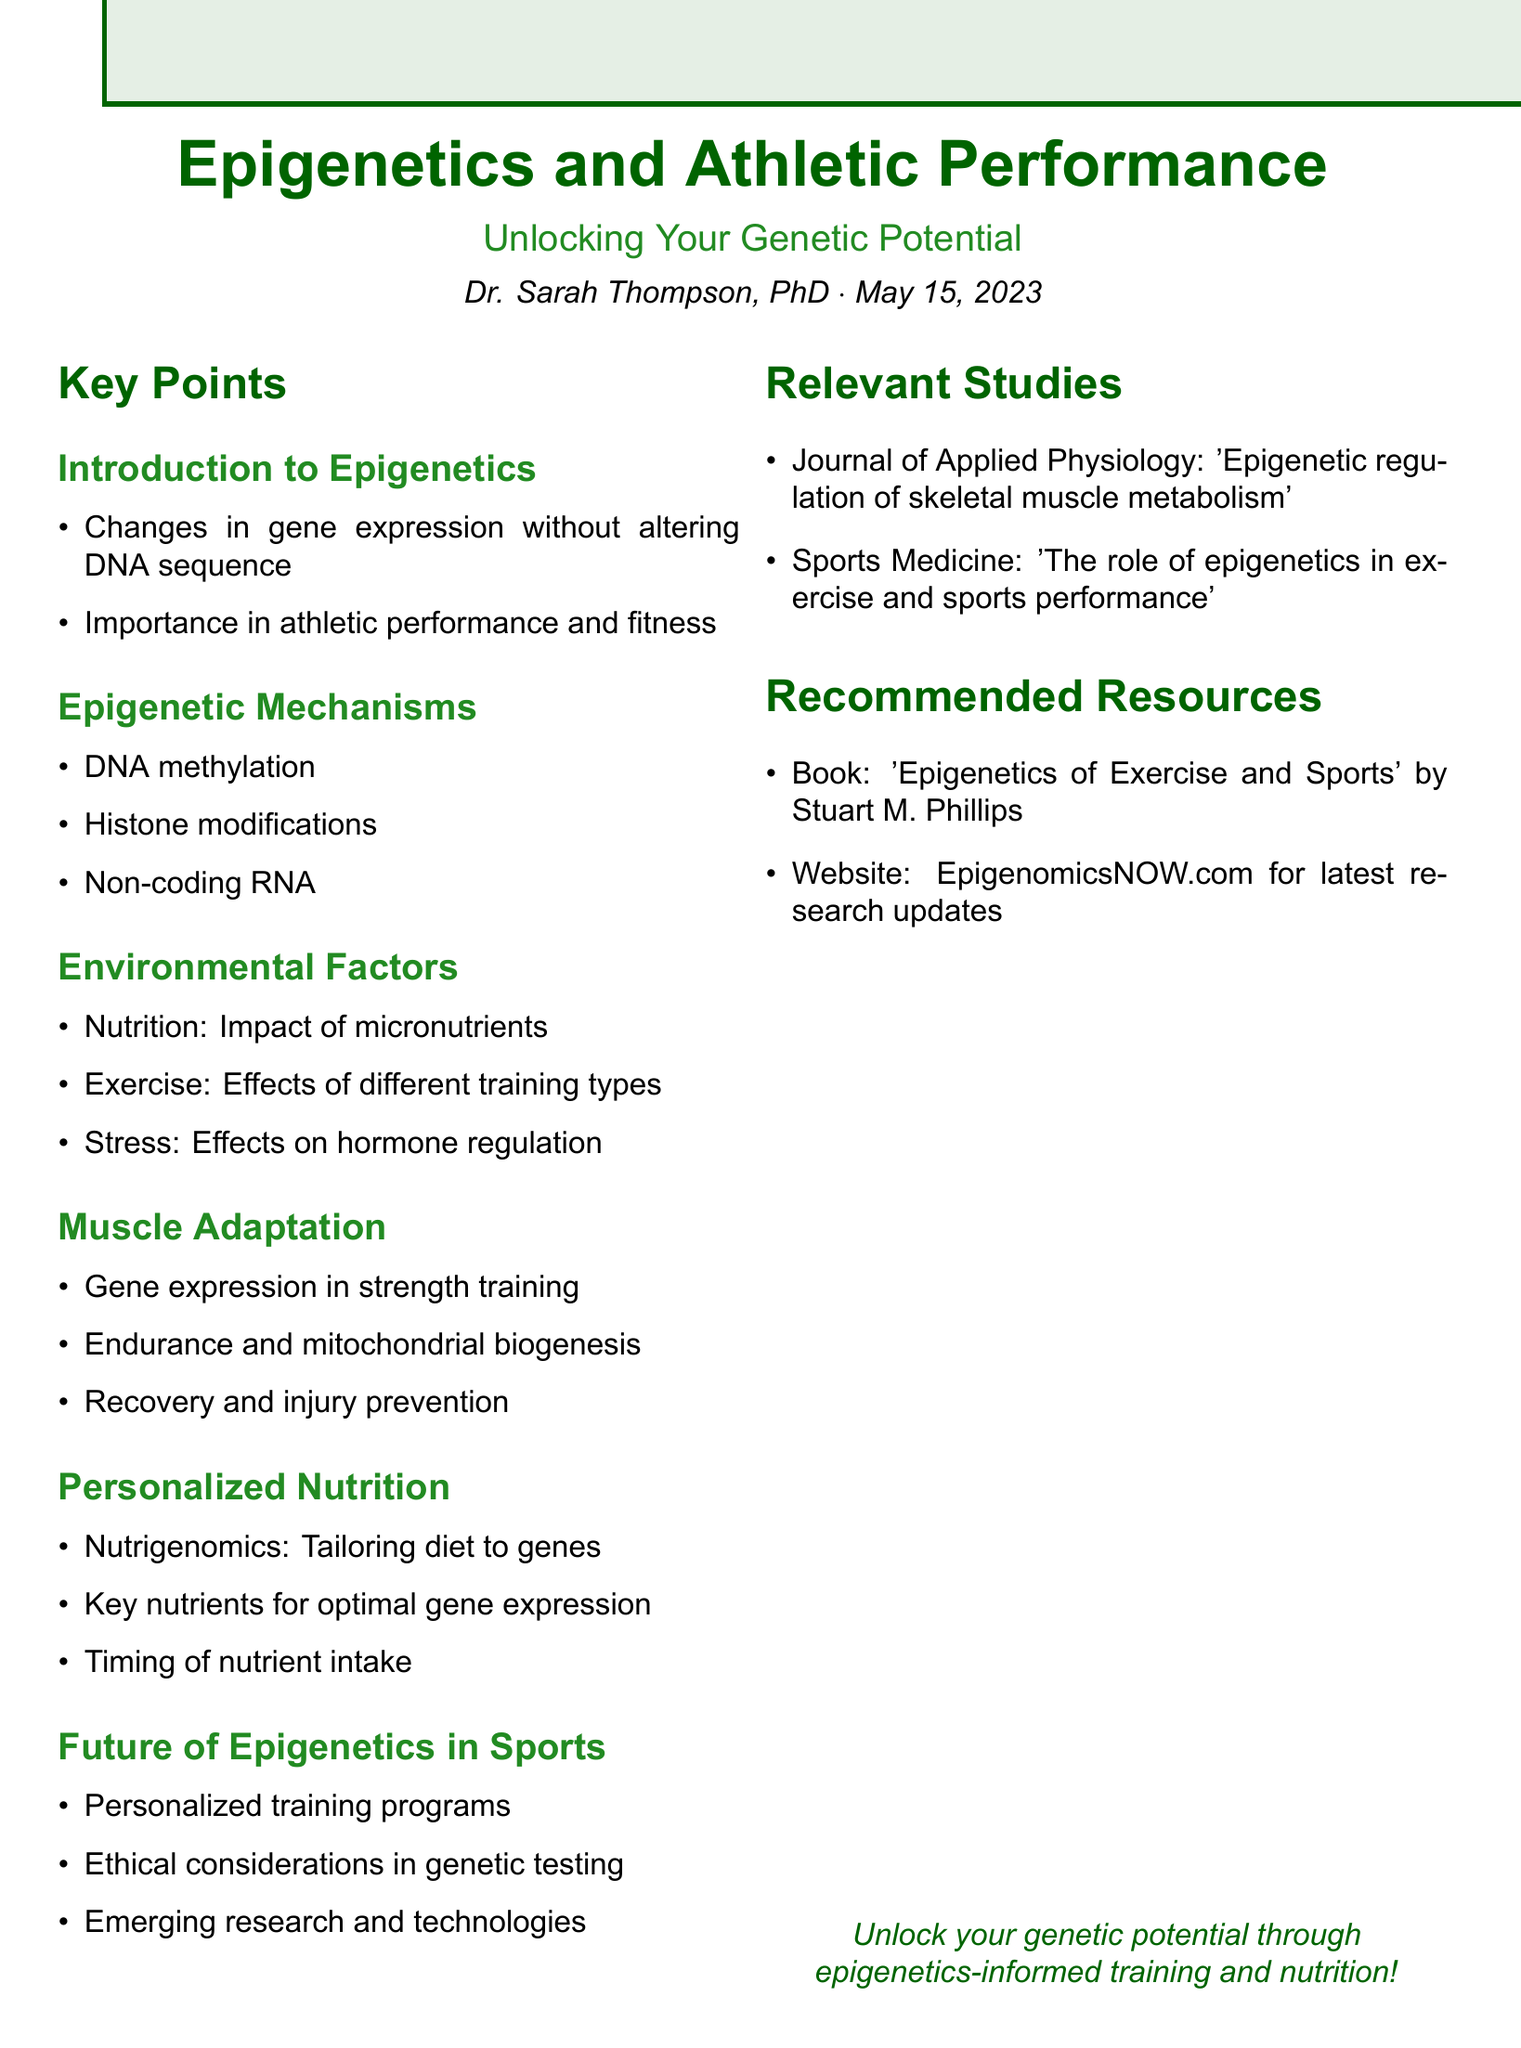What is the seminar title? The seminar title is explicitly mentioned in the document as a main heading.
Answer: Epigenetics and Athletic Performance: Unlocking Your Genetic Potential Who is the speaker? The document provides the name and qualifications of the speaker in the introductory section.
Answer: Dr. Sarah Thompson, PhD in Molecular Biology and Sports Science What is the date of the seminar? The date is provided directly under the speaker's information in the document.
Answer: May 15, 2023 Which epigenetic mechanism involves modifications to histones? This is one of the key points listed in the section on Epigenetic Mechanisms.
Answer: Histone modifications What aspect of nutrition is discussed in relation to epigenetics? The document mentions specific effects of nutrition in the Environmental Factors section.
Answer: Impact of micronutrients on gene expression What role does epigenetics play in muscle adaptation? The document summarizes the effects of epigenetics on muscle adaptation under its relevant section.
Answer: Gene expression changes during strength training What type of training is suggested for personalized nutrition based on epigenetic profiles? This is addressed in the Personalized Nutrition section of the document.
Answer: Nutrigenomics What is a future consideration mentioned for sports related to epigenetics? The document discusses future possibilities in the context of sports and epigenetics.
Answer: Personalized training programs What is the recommended book title included in the resources? The document lists specific resources in a dedicated section.
Answer: Epigenetics of Exercise and Sports Which journal published a study related to epigenetics in exercise? The document lists relevant studies in a section that covers scholarly references.
Answer: Journal of Applied Physiology 